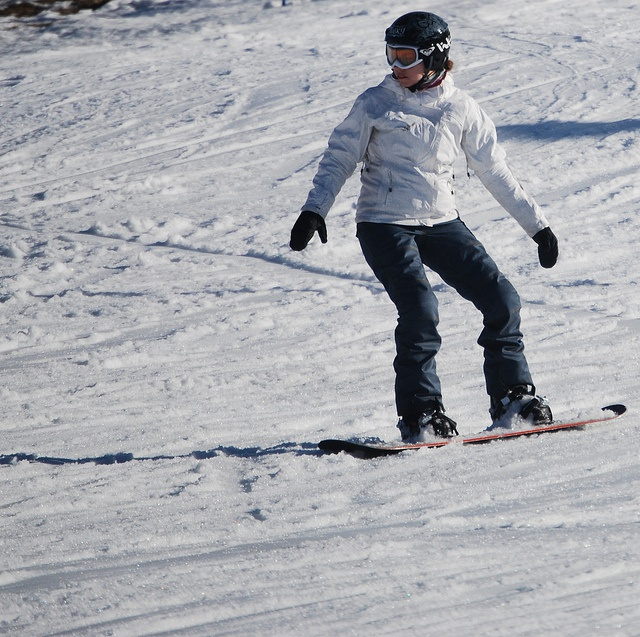Describe the objects in this image and their specific colors. I can see people in gray, black, darkgray, and lightgray tones and snowboard in gray, black, darkgray, lightgray, and brown tones in this image. 